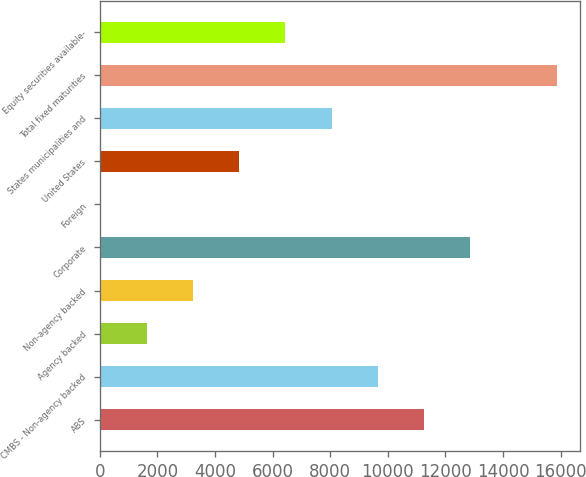Convert chart. <chart><loc_0><loc_0><loc_500><loc_500><bar_chart><fcel>ABS<fcel>CMBS - Non-agency backed<fcel>Agency backed<fcel>Non-agency backed<fcel>Corporate<fcel>Foreign<fcel>United States<fcel>States municipalities and<fcel>Total fixed maturities<fcel>Equity securities available-<nl><fcel>11258.7<fcel>9654.6<fcel>1634.1<fcel>3238.2<fcel>12862.8<fcel>30<fcel>4842.3<fcel>8050.5<fcel>15872<fcel>6446.4<nl></chart> 